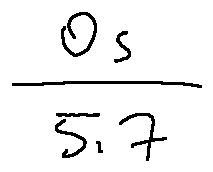Convert formula to latex. <formula><loc_0><loc_0><loc_500><loc_500>\frac { 0 s } { 5 . 7 }</formula> 